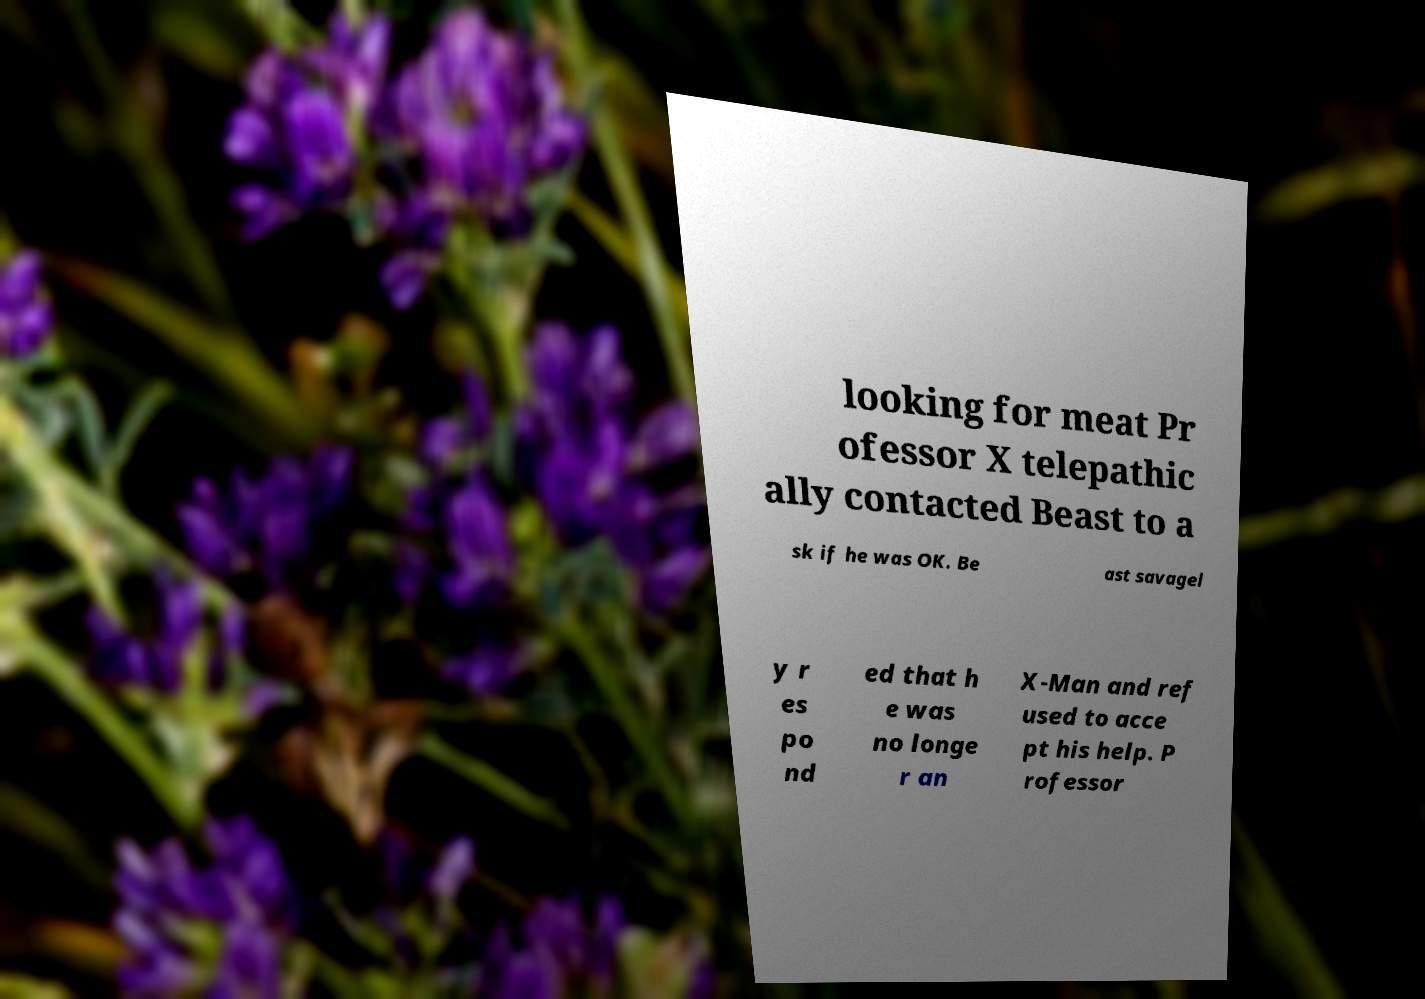Can you read and provide the text displayed in the image?This photo seems to have some interesting text. Can you extract and type it out for me? looking for meat Pr ofessor X telepathic ally contacted Beast to a sk if he was OK. Be ast savagel y r es po nd ed that h e was no longe r an X-Man and ref used to acce pt his help. P rofessor 